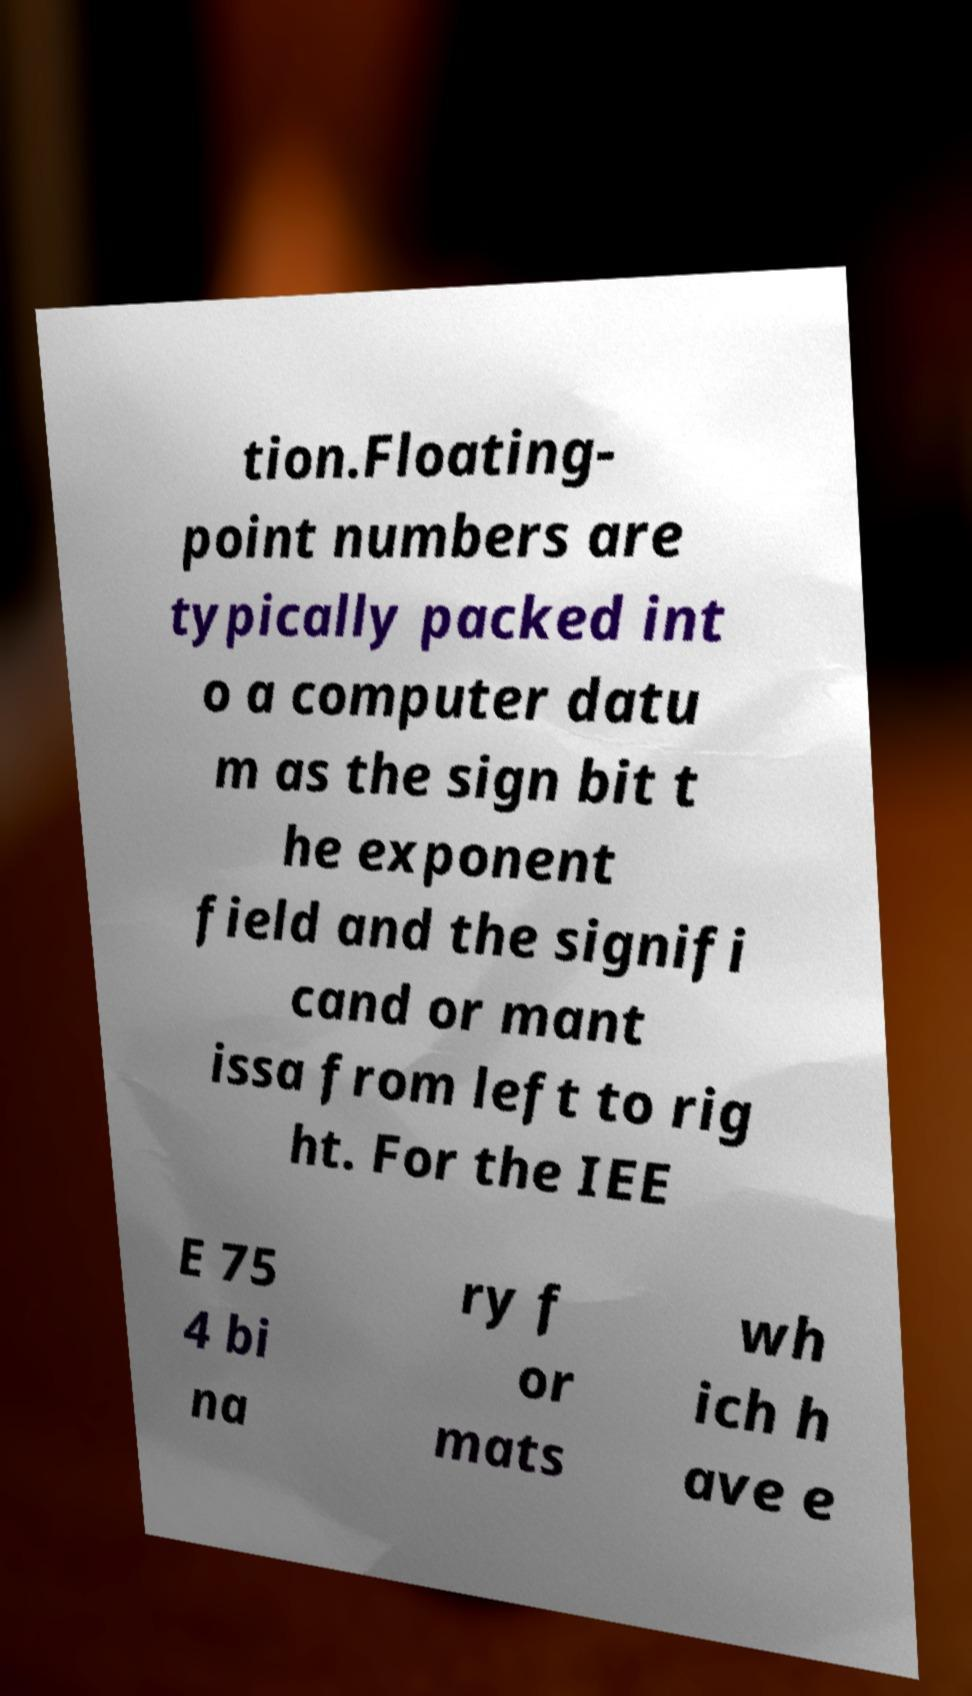Could you extract and type out the text from this image? tion.Floating- point numbers are typically packed int o a computer datu m as the sign bit t he exponent field and the signifi cand or mant issa from left to rig ht. For the IEE E 75 4 bi na ry f or mats wh ich h ave e 